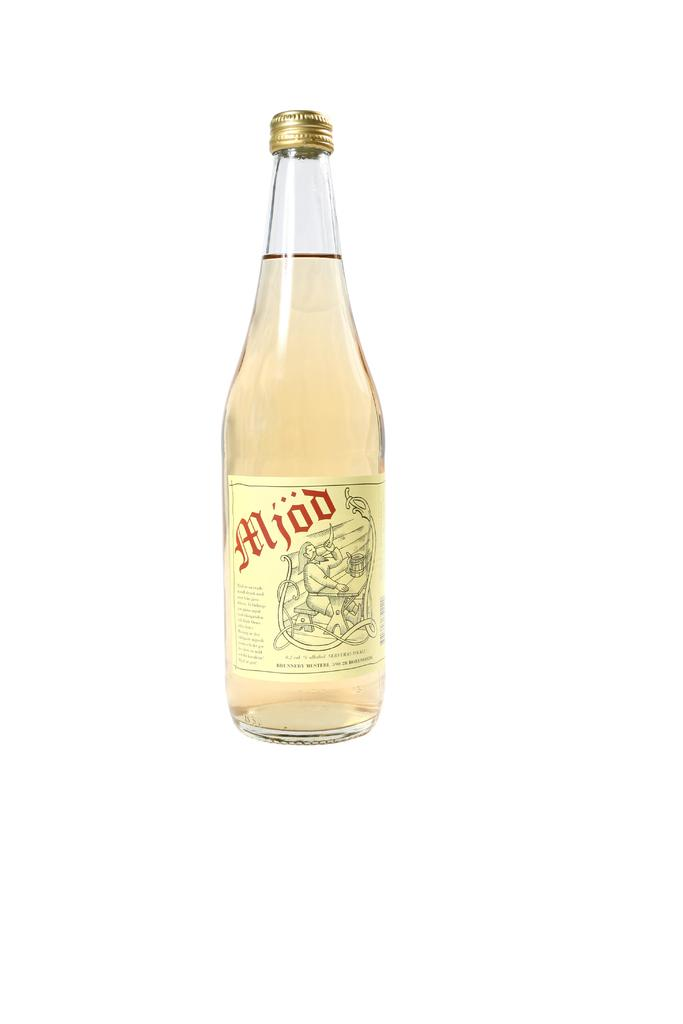<image>
Present a compact description of the photo's key features. The bottle in the picture has Mjod written on it. 